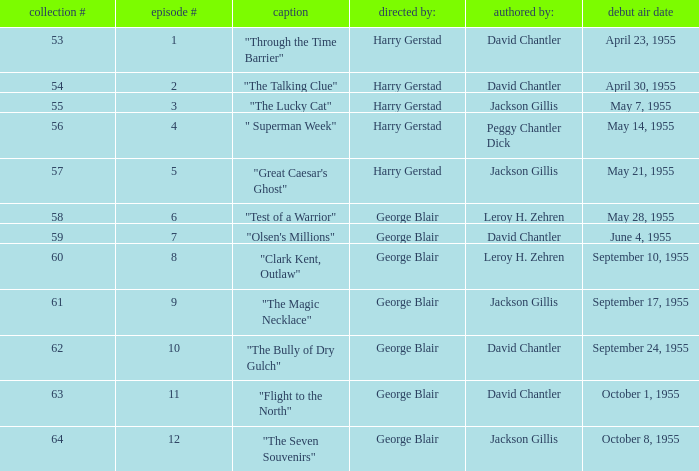Which Season originally aired on September 17, 1955 9.0. 